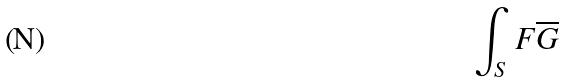<formula> <loc_0><loc_0><loc_500><loc_500>\int _ { S } F \overline { G }</formula> 